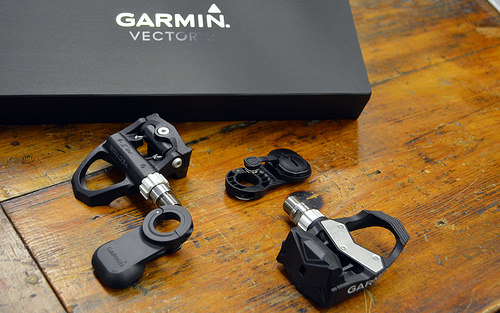<image>
Is there a box behind the table? No. The box is not behind the table. From this viewpoint, the box appears to be positioned elsewhere in the scene. 